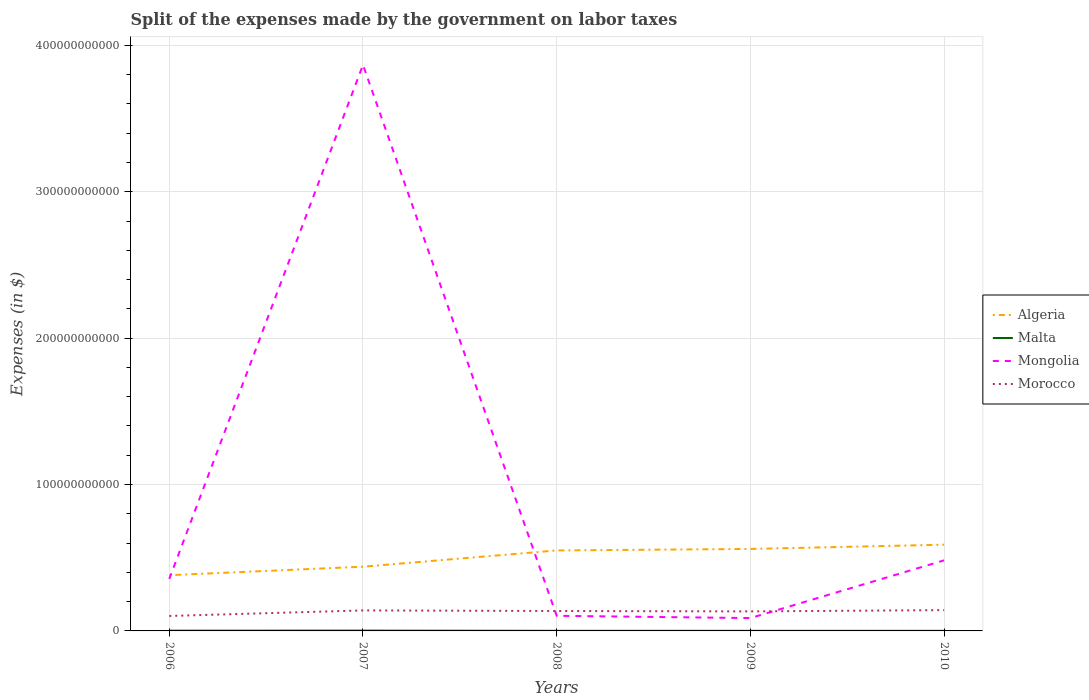How many different coloured lines are there?
Make the answer very short. 4. Across all years, what is the maximum expenses made by the government on labor taxes in Malta?
Your answer should be compact. 6.28e+07. In which year was the expenses made by the government on labor taxes in Malta maximum?
Your answer should be compact. 2009. What is the total expenses made by the government on labor taxes in Algeria in the graph?
Ensure brevity in your answer.  -1.79e+1. What is the difference between the highest and the second highest expenses made by the government on labor taxes in Mongolia?
Make the answer very short. 3.78e+11. How many lines are there?
Provide a short and direct response. 4. How many years are there in the graph?
Your response must be concise. 5. What is the difference between two consecutive major ticks on the Y-axis?
Offer a very short reply. 1.00e+11. Are the values on the major ticks of Y-axis written in scientific E-notation?
Provide a short and direct response. No. Does the graph contain any zero values?
Your answer should be very brief. No. Does the graph contain grids?
Offer a very short reply. Yes. Where does the legend appear in the graph?
Provide a succinct answer. Center right. What is the title of the graph?
Provide a succinct answer. Split of the expenses made by the government on labor taxes. What is the label or title of the X-axis?
Your answer should be very brief. Years. What is the label or title of the Y-axis?
Keep it short and to the point. Expenses (in $). What is the Expenses (in $) in Algeria in 2006?
Make the answer very short. 3.81e+1. What is the Expenses (in $) in Malta in 2006?
Provide a succinct answer. 1.84e+08. What is the Expenses (in $) of Mongolia in 2006?
Make the answer very short. 3.55e+1. What is the Expenses (in $) of Morocco in 2006?
Provide a succinct answer. 1.02e+1. What is the Expenses (in $) of Algeria in 2007?
Your answer should be very brief. 4.39e+1. What is the Expenses (in $) of Malta in 2007?
Your response must be concise. 2.10e+08. What is the Expenses (in $) of Mongolia in 2007?
Your answer should be very brief. 3.87e+11. What is the Expenses (in $) of Morocco in 2007?
Ensure brevity in your answer.  1.40e+1. What is the Expenses (in $) in Algeria in 2008?
Ensure brevity in your answer.  5.50e+1. What is the Expenses (in $) in Malta in 2008?
Offer a very short reply. 7.66e+07. What is the Expenses (in $) in Mongolia in 2008?
Offer a very short reply. 1.03e+1. What is the Expenses (in $) of Morocco in 2008?
Provide a succinct answer. 1.36e+1. What is the Expenses (in $) of Algeria in 2009?
Offer a very short reply. 5.60e+1. What is the Expenses (in $) in Malta in 2009?
Offer a very short reply. 6.28e+07. What is the Expenses (in $) of Mongolia in 2009?
Your answer should be compact. 8.78e+09. What is the Expenses (in $) in Morocco in 2009?
Offer a very short reply. 1.33e+1. What is the Expenses (in $) of Algeria in 2010?
Your answer should be very brief. 5.89e+1. What is the Expenses (in $) in Malta in 2010?
Provide a succinct answer. 6.73e+07. What is the Expenses (in $) of Mongolia in 2010?
Provide a succinct answer. 4.82e+1. What is the Expenses (in $) in Morocco in 2010?
Your response must be concise. 1.42e+1. Across all years, what is the maximum Expenses (in $) of Algeria?
Give a very brief answer. 5.89e+1. Across all years, what is the maximum Expenses (in $) in Malta?
Offer a terse response. 2.10e+08. Across all years, what is the maximum Expenses (in $) in Mongolia?
Offer a very short reply. 3.87e+11. Across all years, what is the maximum Expenses (in $) of Morocco?
Make the answer very short. 1.42e+1. Across all years, what is the minimum Expenses (in $) of Algeria?
Offer a very short reply. 3.81e+1. Across all years, what is the minimum Expenses (in $) in Malta?
Make the answer very short. 6.28e+07. Across all years, what is the minimum Expenses (in $) of Mongolia?
Your answer should be very brief. 8.78e+09. Across all years, what is the minimum Expenses (in $) in Morocco?
Provide a short and direct response. 1.02e+1. What is the total Expenses (in $) in Algeria in the graph?
Your response must be concise. 2.52e+11. What is the total Expenses (in $) of Malta in the graph?
Give a very brief answer. 6.01e+08. What is the total Expenses (in $) of Mongolia in the graph?
Offer a very short reply. 4.90e+11. What is the total Expenses (in $) of Morocco in the graph?
Offer a terse response. 6.54e+1. What is the difference between the Expenses (in $) in Algeria in 2006 and that in 2007?
Provide a short and direct response. -5.81e+09. What is the difference between the Expenses (in $) in Malta in 2006 and that in 2007?
Make the answer very short. -2.54e+07. What is the difference between the Expenses (in $) of Mongolia in 2006 and that in 2007?
Keep it short and to the point. -3.51e+11. What is the difference between the Expenses (in $) in Morocco in 2006 and that in 2007?
Keep it short and to the point. -3.80e+09. What is the difference between the Expenses (in $) in Algeria in 2006 and that in 2008?
Keep it short and to the point. -1.69e+1. What is the difference between the Expenses (in $) of Malta in 2006 and that in 2008?
Provide a short and direct response. 1.08e+08. What is the difference between the Expenses (in $) of Mongolia in 2006 and that in 2008?
Offer a very short reply. 2.52e+1. What is the difference between the Expenses (in $) of Morocco in 2006 and that in 2008?
Give a very brief answer. -3.40e+09. What is the difference between the Expenses (in $) in Algeria in 2006 and that in 2009?
Your answer should be very brief. -1.79e+1. What is the difference between the Expenses (in $) in Malta in 2006 and that in 2009?
Provide a short and direct response. 1.22e+08. What is the difference between the Expenses (in $) in Mongolia in 2006 and that in 2009?
Your answer should be compact. 2.67e+1. What is the difference between the Expenses (in $) of Morocco in 2006 and that in 2009?
Ensure brevity in your answer.  -3.13e+09. What is the difference between the Expenses (in $) in Algeria in 2006 and that in 2010?
Make the answer very short. -2.08e+1. What is the difference between the Expenses (in $) of Malta in 2006 and that in 2010?
Provide a succinct answer. 1.17e+08. What is the difference between the Expenses (in $) in Mongolia in 2006 and that in 2010?
Ensure brevity in your answer.  -1.27e+1. What is the difference between the Expenses (in $) of Morocco in 2006 and that in 2010?
Offer a very short reply. -3.99e+09. What is the difference between the Expenses (in $) in Algeria in 2007 and that in 2008?
Your answer should be compact. -1.11e+1. What is the difference between the Expenses (in $) of Malta in 2007 and that in 2008?
Your response must be concise. 1.33e+08. What is the difference between the Expenses (in $) of Mongolia in 2007 and that in 2008?
Make the answer very short. 3.76e+11. What is the difference between the Expenses (in $) in Morocco in 2007 and that in 2008?
Your answer should be compact. 4.00e+08. What is the difference between the Expenses (in $) of Algeria in 2007 and that in 2009?
Your answer should be compact. -1.21e+1. What is the difference between the Expenses (in $) of Malta in 2007 and that in 2009?
Offer a very short reply. 1.47e+08. What is the difference between the Expenses (in $) of Mongolia in 2007 and that in 2009?
Keep it short and to the point. 3.78e+11. What is the difference between the Expenses (in $) of Morocco in 2007 and that in 2009?
Make the answer very short. 6.70e+08. What is the difference between the Expenses (in $) in Algeria in 2007 and that in 2010?
Offer a very short reply. -1.50e+1. What is the difference between the Expenses (in $) in Malta in 2007 and that in 2010?
Ensure brevity in your answer.  1.42e+08. What is the difference between the Expenses (in $) of Mongolia in 2007 and that in 2010?
Your response must be concise. 3.38e+11. What is the difference between the Expenses (in $) of Morocco in 2007 and that in 2010?
Keep it short and to the point. -1.91e+08. What is the difference between the Expenses (in $) of Algeria in 2008 and that in 2009?
Make the answer very short. -1.03e+09. What is the difference between the Expenses (in $) of Malta in 2008 and that in 2009?
Your answer should be compact. 1.38e+07. What is the difference between the Expenses (in $) of Mongolia in 2008 and that in 2009?
Offer a terse response. 1.55e+09. What is the difference between the Expenses (in $) of Morocco in 2008 and that in 2009?
Give a very brief answer. 2.70e+08. What is the difference between the Expenses (in $) in Algeria in 2008 and that in 2010?
Provide a succinct answer. -3.93e+09. What is the difference between the Expenses (in $) in Malta in 2008 and that in 2010?
Offer a very short reply. 9.32e+06. What is the difference between the Expenses (in $) of Mongolia in 2008 and that in 2010?
Give a very brief answer. -3.79e+1. What is the difference between the Expenses (in $) in Morocco in 2008 and that in 2010?
Make the answer very short. -5.91e+08. What is the difference between the Expenses (in $) in Algeria in 2009 and that in 2010?
Ensure brevity in your answer.  -2.90e+09. What is the difference between the Expenses (in $) of Malta in 2009 and that in 2010?
Provide a short and direct response. -4.52e+06. What is the difference between the Expenses (in $) in Mongolia in 2009 and that in 2010?
Keep it short and to the point. -3.94e+1. What is the difference between the Expenses (in $) of Morocco in 2009 and that in 2010?
Give a very brief answer. -8.61e+08. What is the difference between the Expenses (in $) in Algeria in 2006 and the Expenses (in $) in Malta in 2007?
Give a very brief answer. 3.79e+1. What is the difference between the Expenses (in $) in Algeria in 2006 and the Expenses (in $) in Mongolia in 2007?
Keep it short and to the point. -3.49e+11. What is the difference between the Expenses (in $) in Algeria in 2006 and the Expenses (in $) in Morocco in 2007?
Make the answer very short. 2.41e+1. What is the difference between the Expenses (in $) in Malta in 2006 and the Expenses (in $) in Mongolia in 2007?
Give a very brief answer. -3.86e+11. What is the difference between the Expenses (in $) in Malta in 2006 and the Expenses (in $) in Morocco in 2007?
Ensure brevity in your answer.  -1.38e+1. What is the difference between the Expenses (in $) in Mongolia in 2006 and the Expenses (in $) in Morocco in 2007?
Your response must be concise. 2.15e+1. What is the difference between the Expenses (in $) in Algeria in 2006 and the Expenses (in $) in Malta in 2008?
Ensure brevity in your answer.  3.80e+1. What is the difference between the Expenses (in $) of Algeria in 2006 and the Expenses (in $) of Mongolia in 2008?
Offer a terse response. 2.77e+1. What is the difference between the Expenses (in $) in Algeria in 2006 and the Expenses (in $) in Morocco in 2008?
Ensure brevity in your answer.  2.45e+1. What is the difference between the Expenses (in $) of Malta in 2006 and the Expenses (in $) of Mongolia in 2008?
Your answer should be compact. -1.01e+1. What is the difference between the Expenses (in $) of Malta in 2006 and the Expenses (in $) of Morocco in 2008?
Give a very brief answer. -1.34e+1. What is the difference between the Expenses (in $) in Mongolia in 2006 and the Expenses (in $) in Morocco in 2008?
Make the answer very short. 2.19e+1. What is the difference between the Expenses (in $) of Algeria in 2006 and the Expenses (in $) of Malta in 2009?
Provide a short and direct response. 3.80e+1. What is the difference between the Expenses (in $) in Algeria in 2006 and the Expenses (in $) in Mongolia in 2009?
Your answer should be compact. 2.93e+1. What is the difference between the Expenses (in $) of Algeria in 2006 and the Expenses (in $) of Morocco in 2009?
Keep it short and to the point. 2.47e+1. What is the difference between the Expenses (in $) in Malta in 2006 and the Expenses (in $) in Mongolia in 2009?
Your answer should be compact. -8.60e+09. What is the difference between the Expenses (in $) of Malta in 2006 and the Expenses (in $) of Morocco in 2009?
Keep it short and to the point. -1.32e+1. What is the difference between the Expenses (in $) in Mongolia in 2006 and the Expenses (in $) in Morocco in 2009?
Ensure brevity in your answer.  2.22e+1. What is the difference between the Expenses (in $) of Algeria in 2006 and the Expenses (in $) of Malta in 2010?
Keep it short and to the point. 3.80e+1. What is the difference between the Expenses (in $) in Algeria in 2006 and the Expenses (in $) in Mongolia in 2010?
Make the answer very short. -1.01e+1. What is the difference between the Expenses (in $) of Algeria in 2006 and the Expenses (in $) of Morocco in 2010?
Give a very brief answer. 2.39e+1. What is the difference between the Expenses (in $) in Malta in 2006 and the Expenses (in $) in Mongolia in 2010?
Provide a short and direct response. -4.80e+1. What is the difference between the Expenses (in $) of Malta in 2006 and the Expenses (in $) of Morocco in 2010?
Provide a succinct answer. -1.40e+1. What is the difference between the Expenses (in $) of Mongolia in 2006 and the Expenses (in $) of Morocco in 2010?
Provide a succinct answer. 2.13e+1. What is the difference between the Expenses (in $) in Algeria in 2007 and the Expenses (in $) in Malta in 2008?
Make the answer very short. 4.38e+1. What is the difference between the Expenses (in $) of Algeria in 2007 and the Expenses (in $) of Mongolia in 2008?
Give a very brief answer. 3.35e+1. What is the difference between the Expenses (in $) in Algeria in 2007 and the Expenses (in $) in Morocco in 2008?
Provide a short and direct response. 3.03e+1. What is the difference between the Expenses (in $) of Malta in 2007 and the Expenses (in $) of Mongolia in 2008?
Provide a short and direct response. -1.01e+1. What is the difference between the Expenses (in $) of Malta in 2007 and the Expenses (in $) of Morocco in 2008?
Give a very brief answer. -1.34e+1. What is the difference between the Expenses (in $) of Mongolia in 2007 and the Expenses (in $) of Morocco in 2008?
Offer a terse response. 3.73e+11. What is the difference between the Expenses (in $) in Algeria in 2007 and the Expenses (in $) in Malta in 2009?
Make the answer very short. 4.38e+1. What is the difference between the Expenses (in $) of Algeria in 2007 and the Expenses (in $) of Mongolia in 2009?
Ensure brevity in your answer.  3.51e+1. What is the difference between the Expenses (in $) in Algeria in 2007 and the Expenses (in $) in Morocco in 2009?
Provide a short and direct response. 3.05e+1. What is the difference between the Expenses (in $) in Malta in 2007 and the Expenses (in $) in Mongolia in 2009?
Offer a terse response. -8.57e+09. What is the difference between the Expenses (in $) of Malta in 2007 and the Expenses (in $) of Morocco in 2009?
Your answer should be very brief. -1.31e+1. What is the difference between the Expenses (in $) of Mongolia in 2007 and the Expenses (in $) of Morocco in 2009?
Offer a terse response. 3.73e+11. What is the difference between the Expenses (in $) in Algeria in 2007 and the Expenses (in $) in Malta in 2010?
Keep it short and to the point. 4.38e+1. What is the difference between the Expenses (in $) in Algeria in 2007 and the Expenses (in $) in Mongolia in 2010?
Your answer should be very brief. -4.33e+09. What is the difference between the Expenses (in $) in Algeria in 2007 and the Expenses (in $) in Morocco in 2010?
Make the answer very short. 2.97e+1. What is the difference between the Expenses (in $) of Malta in 2007 and the Expenses (in $) of Mongolia in 2010?
Provide a succinct answer. -4.80e+1. What is the difference between the Expenses (in $) in Malta in 2007 and the Expenses (in $) in Morocco in 2010?
Give a very brief answer. -1.40e+1. What is the difference between the Expenses (in $) in Mongolia in 2007 and the Expenses (in $) in Morocco in 2010?
Your answer should be compact. 3.72e+11. What is the difference between the Expenses (in $) in Algeria in 2008 and the Expenses (in $) in Malta in 2009?
Keep it short and to the point. 5.49e+1. What is the difference between the Expenses (in $) in Algeria in 2008 and the Expenses (in $) in Mongolia in 2009?
Provide a succinct answer. 4.62e+1. What is the difference between the Expenses (in $) in Algeria in 2008 and the Expenses (in $) in Morocco in 2009?
Keep it short and to the point. 4.16e+1. What is the difference between the Expenses (in $) of Malta in 2008 and the Expenses (in $) of Mongolia in 2009?
Your answer should be compact. -8.70e+09. What is the difference between the Expenses (in $) in Malta in 2008 and the Expenses (in $) in Morocco in 2009?
Your answer should be very brief. -1.33e+1. What is the difference between the Expenses (in $) in Mongolia in 2008 and the Expenses (in $) in Morocco in 2009?
Ensure brevity in your answer.  -3.01e+09. What is the difference between the Expenses (in $) of Algeria in 2008 and the Expenses (in $) of Malta in 2010?
Ensure brevity in your answer.  5.49e+1. What is the difference between the Expenses (in $) in Algeria in 2008 and the Expenses (in $) in Mongolia in 2010?
Provide a short and direct response. 6.76e+09. What is the difference between the Expenses (in $) of Algeria in 2008 and the Expenses (in $) of Morocco in 2010?
Your response must be concise. 4.08e+1. What is the difference between the Expenses (in $) in Malta in 2008 and the Expenses (in $) in Mongolia in 2010?
Make the answer very short. -4.81e+1. What is the difference between the Expenses (in $) in Malta in 2008 and the Expenses (in $) in Morocco in 2010?
Your response must be concise. -1.41e+1. What is the difference between the Expenses (in $) of Mongolia in 2008 and the Expenses (in $) of Morocco in 2010?
Ensure brevity in your answer.  -3.87e+09. What is the difference between the Expenses (in $) in Algeria in 2009 and the Expenses (in $) in Malta in 2010?
Provide a succinct answer. 5.59e+1. What is the difference between the Expenses (in $) in Algeria in 2009 and the Expenses (in $) in Mongolia in 2010?
Your answer should be very brief. 7.79e+09. What is the difference between the Expenses (in $) of Algeria in 2009 and the Expenses (in $) of Morocco in 2010?
Give a very brief answer. 4.18e+1. What is the difference between the Expenses (in $) of Malta in 2009 and the Expenses (in $) of Mongolia in 2010?
Your answer should be very brief. -4.81e+1. What is the difference between the Expenses (in $) of Malta in 2009 and the Expenses (in $) of Morocco in 2010?
Offer a very short reply. -1.41e+1. What is the difference between the Expenses (in $) in Mongolia in 2009 and the Expenses (in $) in Morocco in 2010?
Provide a succinct answer. -5.42e+09. What is the average Expenses (in $) of Algeria per year?
Provide a succinct answer. 5.04e+1. What is the average Expenses (in $) in Malta per year?
Provide a short and direct response. 1.20e+08. What is the average Expenses (in $) in Mongolia per year?
Offer a terse response. 9.79e+1. What is the average Expenses (in $) in Morocco per year?
Ensure brevity in your answer.  1.31e+1. In the year 2006, what is the difference between the Expenses (in $) of Algeria and Expenses (in $) of Malta?
Your answer should be very brief. 3.79e+1. In the year 2006, what is the difference between the Expenses (in $) of Algeria and Expenses (in $) of Mongolia?
Your response must be concise. 2.55e+09. In the year 2006, what is the difference between the Expenses (in $) in Algeria and Expenses (in $) in Morocco?
Your answer should be very brief. 2.79e+1. In the year 2006, what is the difference between the Expenses (in $) in Malta and Expenses (in $) in Mongolia?
Your response must be concise. -3.53e+1. In the year 2006, what is the difference between the Expenses (in $) of Malta and Expenses (in $) of Morocco?
Provide a succinct answer. -1.00e+1. In the year 2006, what is the difference between the Expenses (in $) in Mongolia and Expenses (in $) in Morocco?
Give a very brief answer. 2.53e+1. In the year 2007, what is the difference between the Expenses (in $) of Algeria and Expenses (in $) of Malta?
Your response must be concise. 4.37e+1. In the year 2007, what is the difference between the Expenses (in $) in Algeria and Expenses (in $) in Mongolia?
Provide a short and direct response. -3.43e+11. In the year 2007, what is the difference between the Expenses (in $) of Algeria and Expenses (in $) of Morocco?
Offer a terse response. 2.99e+1. In the year 2007, what is the difference between the Expenses (in $) of Malta and Expenses (in $) of Mongolia?
Offer a very short reply. -3.86e+11. In the year 2007, what is the difference between the Expenses (in $) in Malta and Expenses (in $) in Morocco?
Make the answer very short. -1.38e+1. In the year 2007, what is the difference between the Expenses (in $) in Mongolia and Expenses (in $) in Morocco?
Offer a terse response. 3.73e+11. In the year 2008, what is the difference between the Expenses (in $) in Algeria and Expenses (in $) in Malta?
Provide a short and direct response. 5.49e+1. In the year 2008, what is the difference between the Expenses (in $) of Algeria and Expenses (in $) of Mongolia?
Your response must be concise. 4.46e+1. In the year 2008, what is the difference between the Expenses (in $) of Algeria and Expenses (in $) of Morocco?
Offer a terse response. 4.14e+1. In the year 2008, what is the difference between the Expenses (in $) of Malta and Expenses (in $) of Mongolia?
Make the answer very short. -1.03e+1. In the year 2008, what is the difference between the Expenses (in $) in Malta and Expenses (in $) in Morocco?
Offer a terse response. -1.35e+1. In the year 2008, what is the difference between the Expenses (in $) in Mongolia and Expenses (in $) in Morocco?
Make the answer very short. -3.28e+09. In the year 2009, what is the difference between the Expenses (in $) in Algeria and Expenses (in $) in Malta?
Offer a terse response. 5.59e+1. In the year 2009, what is the difference between the Expenses (in $) in Algeria and Expenses (in $) in Mongolia?
Give a very brief answer. 4.72e+1. In the year 2009, what is the difference between the Expenses (in $) in Algeria and Expenses (in $) in Morocco?
Your answer should be compact. 4.27e+1. In the year 2009, what is the difference between the Expenses (in $) of Malta and Expenses (in $) of Mongolia?
Keep it short and to the point. -8.72e+09. In the year 2009, what is the difference between the Expenses (in $) in Malta and Expenses (in $) in Morocco?
Offer a very short reply. -1.33e+1. In the year 2009, what is the difference between the Expenses (in $) of Mongolia and Expenses (in $) of Morocco?
Give a very brief answer. -4.56e+09. In the year 2010, what is the difference between the Expenses (in $) of Algeria and Expenses (in $) of Malta?
Give a very brief answer. 5.88e+1. In the year 2010, what is the difference between the Expenses (in $) in Algeria and Expenses (in $) in Mongolia?
Provide a short and direct response. 1.07e+1. In the year 2010, what is the difference between the Expenses (in $) of Algeria and Expenses (in $) of Morocco?
Your response must be concise. 4.47e+1. In the year 2010, what is the difference between the Expenses (in $) in Malta and Expenses (in $) in Mongolia?
Keep it short and to the point. -4.81e+1. In the year 2010, what is the difference between the Expenses (in $) of Malta and Expenses (in $) of Morocco?
Your answer should be very brief. -1.41e+1. In the year 2010, what is the difference between the Expenses (in $) of Mongolia and Expenses (in $) of Morocco?
Your answer should be compact. 3.40e+1. What is the ratio of the Expenses (in $) in Algeria in 2006 to that in 2007?
Keep it short and to the point. 0.87. What is the ratio of the Expenses (in $) of Malta in 2006 to that in 2007?
Give a very brief answer. 0.88. What is the ratio of the Expenses (in $) in Mongolia in 2006 to that in 2007?
Make the answer very short. 0.09. What is the ratio of the Expenses (in $) of Morocco in 2006 to that in 2007?
Your answer should be very brief. 0.73. What is the ratio of the Expenses (in $) in Algeria in 2006 to that in 2008?
Your answer should be compact. 0.69. What is the ratio of the Expenses (in $) of Malta in 2006 to that in 2008?
Provide a succinct answer. 2.41. What is the ratio of the Expenses (in $) in Mongolia in 2006 to that in 2008?
Offer a terse response. 3.44. What is the ratio of the Expenses (in $) in Morocco in 2006 to that in 2008?
Your answer should be compact. 0.75. What is the ratio of the Expenses (in $) in Algeria in 2006 to that in 2009?
Make the answer very short. 0.68. What is the ratio of the Expenses (in $) in Malta in 2006 to that in 2009?
Your answer should be compact. 2.94. What is the ratio of the Expenses (in $) in Mongolia in 2006 to that in 2009?
Ensure brevity in your answer.  4.05. What is the ratio of the Expenses (in $) in Morocco in 2006 to that in 2009?
Offer a terse response. 0.77. What is the ratio of the Expenses (in $) in Algeria in 2006 to that in 2010?
Give a very brief answer. 0.65. What is the ratio of the Expenses (in $) of Malta in 2006 to that in 2010?
Provide a succinct answer. 2.74. What is the ratio of the Expenses (in $) of Mongolia in 2006 to that in 2010?
Ensure brevity in your answer.  0.74. What is the ratio of the Expenses (in $) of Morocco in 2006 to that in 2010?
Give a very brief answer. 0.72. What is the ratio of the Expenses (in $) in Algeria in 2007 to that in 2008?
Offer a very short reply. 0.8. What is the ratio of the Expenses (in $) in Malta in 2007 to that in 2008?
Offer a very short reply. 2.74. What is the ratio of the Expenses (in $) of Mongolia in 2007 to that in 2008?
Your response must be concise. 37.43. What is the ratio of the Expenses (in $) in Morocco in 2007 to that in 2008?
Offer a very short reply. 1.03. What is the ratio of the Expenses (in $) of Algeria in 2007 to that in 2009?
Your answer should be compact. 0.78. What is the ratio of the Expenses (in $) of Malta in 2007 to that in 2009?
Your answer should be very brief. 3.34. What is the ratio of the Expenses (in $) in Mongolia in 2007 to that in 2009?
Provide a succinct answer. 44.04. What is the ratio of the Expenses (in $) in Morocco in 2007 to that in 2009?
Offer a terse response. 1.05. What is the ratio of the Expenses (in $) in Algeria in 2007 to that in 2010?
Offer a very short reply. 0.74. What is the ratio of the Expenses (in $) of Malta in 2007 to that in 2010?
Provide a succinct answer. 3.12. What is the ratio of the Expenses (in $) in Mongolia in 2007 to that in 2010?
Your response must be concise. 8.02. What is the ratio of the Expenses (in $) in Morocco in 2007 to that in 2010?
Make the answer very short. 0.99. What is the ratio of the Expenses (in $) in Algeria in 2008 to that in 2009?
Your answer should be very brief. 0.98. What is the ratio of the Expenses (in $) of Malta in 2008 to that in 2009?
Offer a very short reply. 1.22. What is the ratio of the Expenses (in $) of Mongolia in 2008 to that in 2009?
Ensure brevity in your answer.  1.18. What is the ratio of the Expenses (in $) in Morocco in 2008 to that in 2009?
Offer a terse response. 1.02. What is the ratio of the Expenses (in $) of Algeria in 2008 to that in 2010?
Your response must be concise. 0.93. What is the ratio of the Expenses (in $) in Malta in 2008 to that in 2010?
Offer a very short reply. 1.14. What is the ratio of the Expenses (in $) in Mongolia in 2008 to that in 2010?
Provide a succinct answer. 0.21. What is the ratio of the Expenses (in $) in Morocco in 2008 to that in 2010?
Offer a very short reply. 0.96. What is the ratio of the Expenses (in $) in Algeria in 2009 to that in 2010?
Offer a terse response. 0.95. What is the ratio of the Expenses (in $) of Malta in 2009 to that in 2010?
Ensure brevity in your answer.  0.93. What is the ratio of the Expenses (in $) of Mongolia in 2009 to that in 2010?
Offer a very short reply. 0.18. What is the ratio of the Expenses (in $) of Morocco in 2009 to that in 2010?
Keep it short and to the point. 0.94. What is the difference between the highest and the second highest Expenses (in $) in Algeria?
Your answer should be very brief. 2.90e+09. What is the difference between the highest and the second highest Expenses (in $) in Malta?
Your answer should be very brief. 2.54e+07. What is the difference between the highest and the second highest Expenses (in $) of Mongolia?
Your answer should be compact. 3.38e+11. What is the difference between the highest and the second highest Expenses (in $) of Morocco?
Your response must be concise. 1.91e+08. What is the difference between the highest and the lowest Expenses (in $) in Algeria?
Offer a terse response. 2.08e+1. What is the difference between the highest and the lowest Expenses (in $) in Malta?
Make the answer very short. 1.47e+08. What is the difference between the highest and the lowest Expenses (in $) of Mongolia?
Provide a short and direct response. 3.78e+11. What is the difference between the highest and the lowest Expenses (in $) in Morocco?
Give a very brief answer. 3.99e+09. 